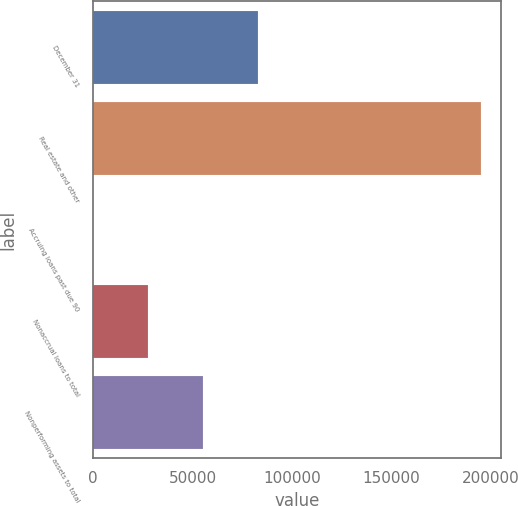Convert chart to OTSL. <chart><loc_0><loc_0><loc_500><loc_500><bar_chart><fcel>December 31<fcel>Real estate and other<fcel>Accruing loans past due 90<fcel>Nonaccrual loans to total<fcel>Nonperforming assets to total<nl><fcel>82885.7<fcel>195085<fcel>0.36<fcel>27628.8<fcel>55257.3<nl></chart> 